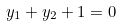<formula> <loc_0><loc_0><loc_500><loc_500>y _ { 1 } + y _ { 2 } + 1 = 0</formula> 